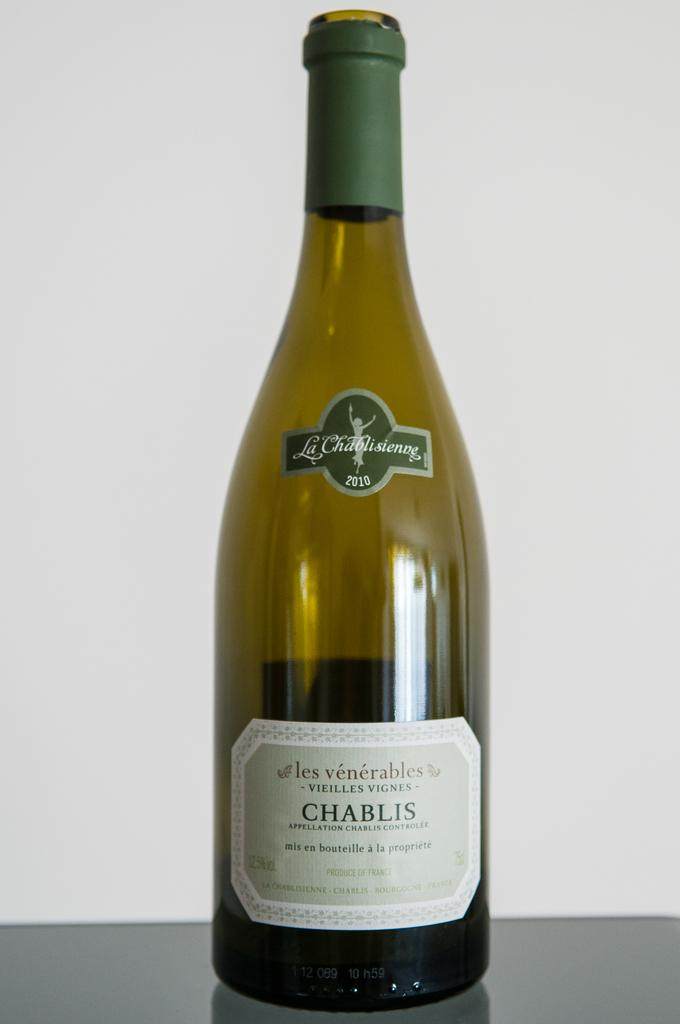What is present in the image? There is a bottle in the image. What is the bottle placed on? The bottle is on an object. What can be seen behind the bottle? There is a white wall behind the bottle. What type of pancake is being flipped in the image? There is no pancake present in the image; it only features a bottle on an object with a white wall in the background. 